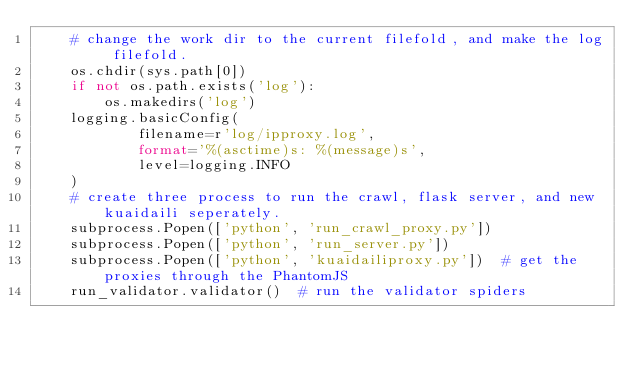Convert code to text. <code><loc_0><loc_0><loc_500><loc_500><_Python_>    # change the work dir to the current filefold, and make the log filefold.
    os.chdir(sys.path[0])
    if not os.path.exists('log'):
        os.makedirs('log')
    logging.basicConfig(
            filename=r'log/ipproxy.log',
            format='%(asctime)s: %(message)s',
            level=logging.INFO
    )
    # create three process to run the crawl, flask server, and new kuaidaili seperately.
    subprocess.Popen(['python', 'run_crawl_proxy.py'])
    subprocess.Popen(['python', 'run_server.py'])
    subprocess.Popen(['python', 'kuaidailiproxy.py'])  # get the proxies through the PhantomJS
    run_validator.validator()  # run the validator spiders


</code> 